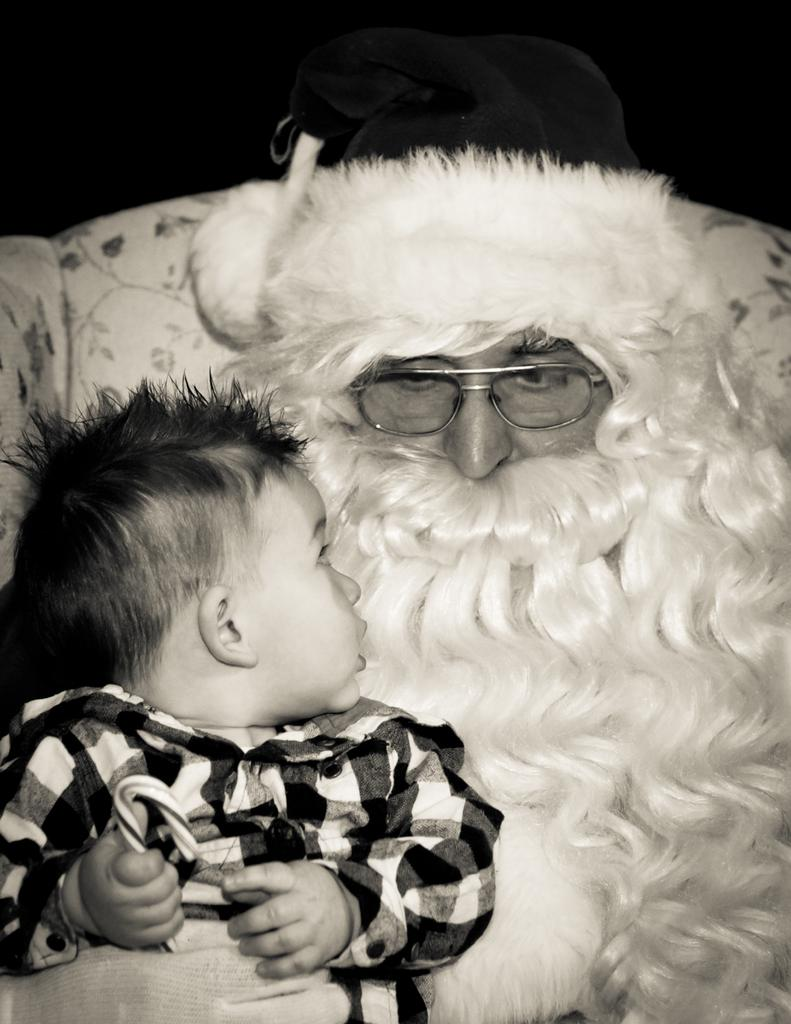What type of picture is in the image? The image contains a black and white picture. Who is depicted in the picture? The picture depicts Santa wearing spectacles. What else is shown in the picture? The picture also shows a baby wearing clothes. What piece of furniture is in the image? There is a couch in the image. How would you describe the overall lighting in the image? The background of the image is dark. What type of pin can be seen holding the baby's clothes together in the image? There is no pin visible in the image; the baby's clothes are not being held together by a pin. What color is the blood on Santa's spectacles in the image? There is no blood present on Santa's spectacles in the image. 